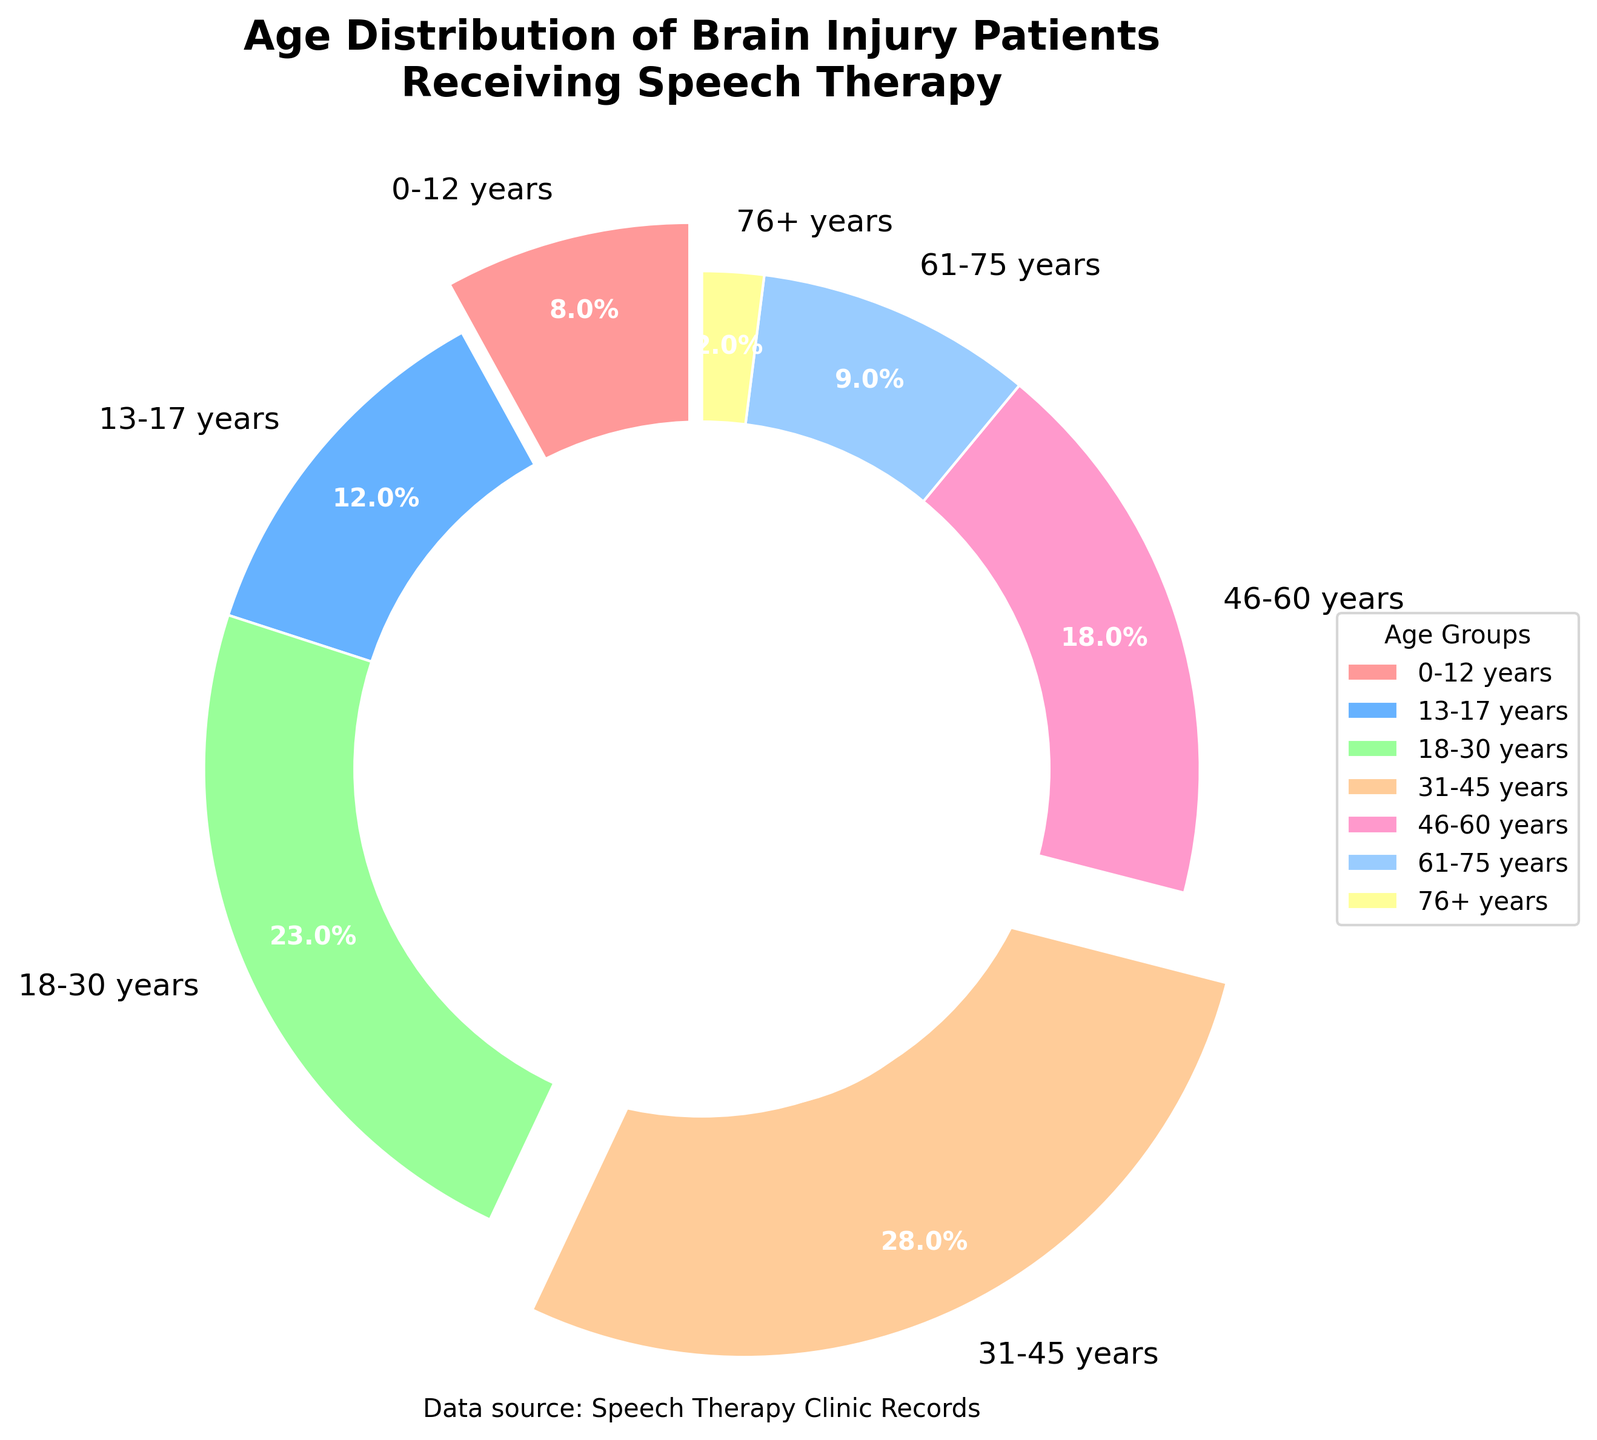What's the largest age group of brain injury patients receiving speech therapy? The pie chart shows the age distribution of brain injury patients. The largest segment represents ages 31-45 years.
Answer: 31-45 years Which age group has the smallest percentage of patients receiving speech therapy? The pie chart indicates the smallest segment, which represents ages 76+ years, with the least percentage.
Answer: 76+ years What is the combined percentage of patients aged 0-30 years? The percentages for 0-12 years, 13-17 years, and 18-30 years are 8%, 12%, and 23% respectively. Their combined percentage is 8 + 12 + 23 = 43%.
Answer: 43% Are there more patients aged 46-60 years or 61+ years? The pie chart shows 18% for ages 46-60 years and a combined 11% for ages 61-75 years (9%) and 76+ years (2%). Therefore, there are more patients aged 46-60 years.
Answer: 46-60 years What are the colors used to represent the age groups in the pie chart? The chart uses distinct colors for each age group. The colors are: 0-12 years (red), 13-17 years (blue), 18-30 years (green), 31-45 years (orange), 46-60 years (pink), 61-75 years (light blue), and 76+ years (yellow).
Answer: Red, Blue, Green, Orange, Pink, Light Blue, Yellow By how much does the percentage of patients aged 18-30 years differ from those aged 31-45 years? The percentage for patients aged 18-30 years is 23%, and for those aged 31-45 years, it is 28%. The difference is 28 - 23 = 5%.
Answer: 5% What percentage of patients fall within the 31-60 years age range? The sum of percentages for the 31-45 years (28%) and 46-60 years (18%) age groups is 28 + 18 = 46%.
Answer: 46% Which two age groups have the closest percentages of patients? By looking at the pie chart, the closest percentages are for 0-12 years (8%) and 61-75 years (9%), with only a 1% difference.
Answer: 0-12 years and 61-75 years 